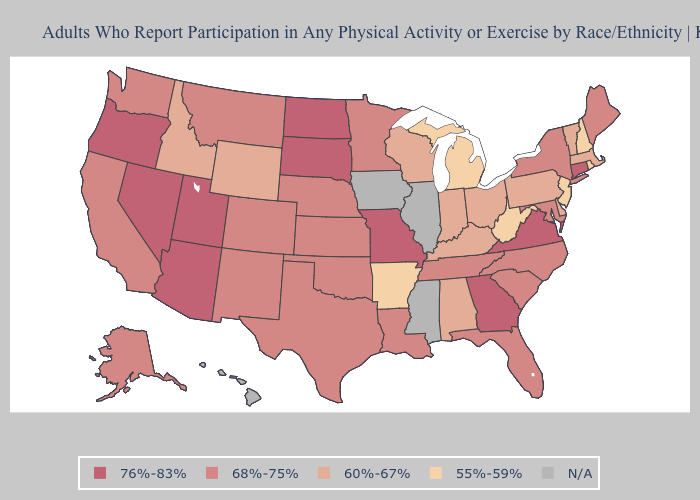Does the first symbol in the legend represent the smallest category?
Quick response, please. No. Among the states that border Nebraska , does Wyoming have the highest value?
Concise answer only. No. Does Minnesota have the highest value in the MidWest?
Give a very brief answer. No. Among the states that border Arkansas , which have the lowest value?
Concise answer only. Louisiana, Oklahoma, Tennessee, Texas. Does the map have missing data?
Be succinct. Yes. Name the states that have a value in the range N/A?
Give a very brief answer. Hawaii, Illinois, Iowa, Mississippi. Name the states that have a value in the range 68%-75%?
Concise answer only. Alaska, California, Colorado, Florida, Kansas, Louisiana, Maine, Maryland, Minnesota, Montana, Nebraska, New Mexico, New York, North Carolina, Oklahoma, South Carolina, Tennessee, Texas, Washington. What is the value of Maryland?
Concise answer only. 68%-75%. What is the highest value in states that border Pennsylvania?
Keep it brief. 68%-75%. Which states have the lowest value in the South?
Be succinct. Arkansas, West Virginia. What is the value of Nebraska?
Quick response, please. 68%-75%. Name the states that have a value in the range 68%-75%?
Short answer required. Alaska, California, Colorado, Florida, Kansas, Louisiana, Maine, Maryland, Minnesota, Montana, Nebraska, New Mexico, New York, North Carolina, Oklahoma, South Carolina, Tennessee, Texas, Washington. Name the states that have a value in the range 76%-83%?
Quick response, please. Arizona, Connecticut, Georgia, Missouri, Nevada, North Dakota, Oregon, South Dakota, Utah, Virginia. What is the lowest value in the South?
Keep it brief. 55%-59%. Which states hav the highest value in the South?
Concise answer only. Georgia, Virginia. 